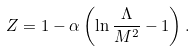<formula> <loc_0><loc_0><loc_500><loc_500>Z = 1 - \alpha \left ( \ln \frac { \Lambda } { M ^ { 2 } } - 1 \right ) .</formula> 